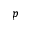<formula> <loc_0><loc_0><loc_500><loc_500>p</formula> 